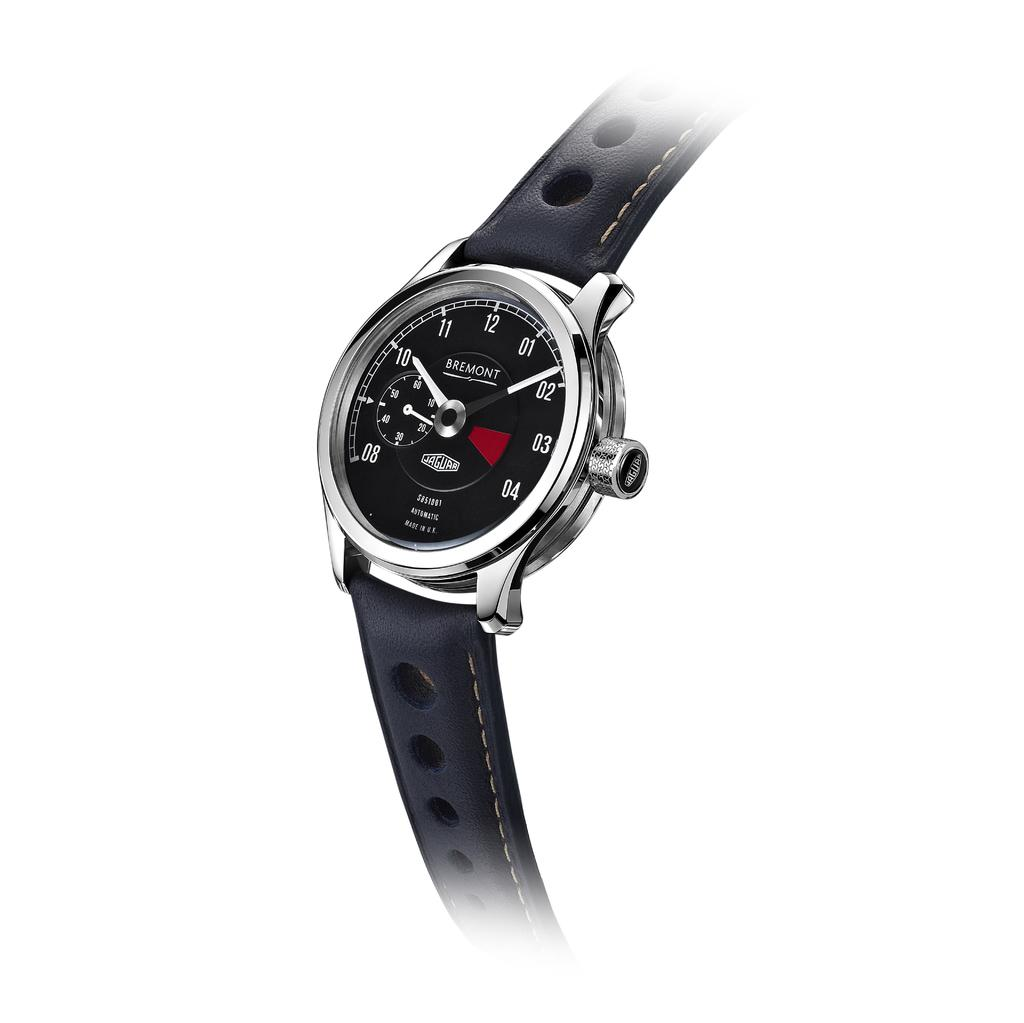<image>
Share a concise interpretation of the image provided. Black and silver watch which says BREMONT on it. 